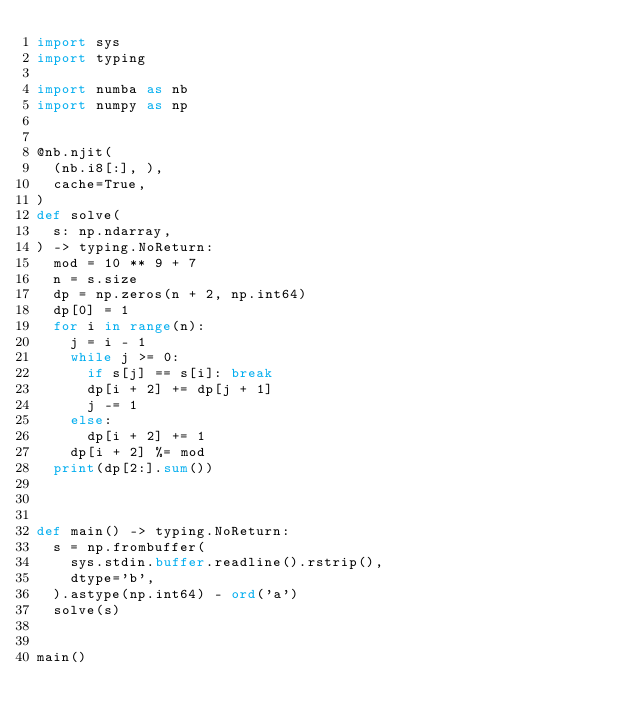<code> <loc_0><loc_0><loc_500><loc_500><_Python_>import sys
import typing

import numba as nb
import numpy as np


@nb.njit(
  (nb.i8[:], ),
  cache=True,
)
def solve(
  s: np.ndarray,
) -> typing.NoReturn:
  mod = 10 ** 9 + 7
  n = s.size
  dp = np.zeros(n + 2, np.int64)
  dp[0] = 1
  for i in range(n):
    j = i - 1
    while j >= 0:
      if s[j] == s[i]: break
      dp[i + 2] += dp[j + 1]
      j -= 1
    else:
      dp[i + 2] += 1
    dp[i + 2] %= mod
  print(dp[2:].sum())



def main() -> typing.NoReturn:
  s = np.frombuffer(
    sys.stdin.buffer.readline().rstrip(),
    dtype='b',
  ).astype(np.int64) - ord('a')
  solve(s)


main()
</code> 